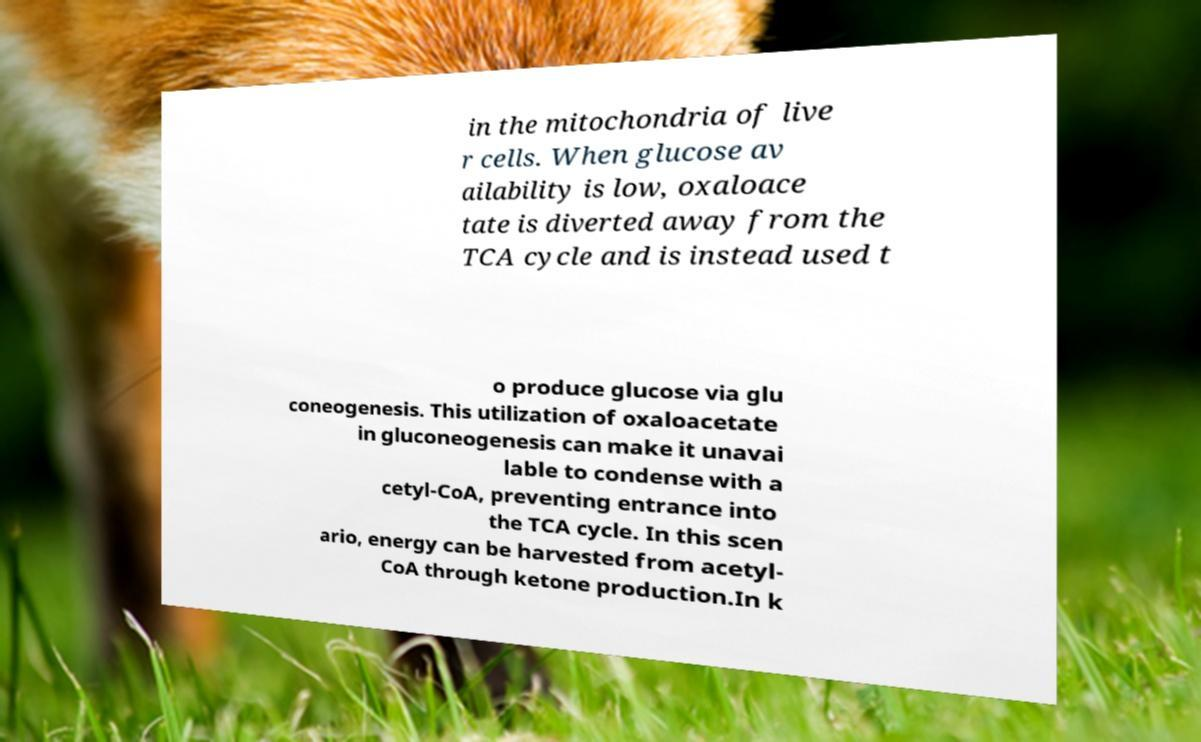Could you assist in decoding the text presented in this image and type it out clearly? in the mitochondria of live r cells. When glucose av ailability is low, oxaloace tate is diverted away from the TCA cycle and is instead used t o produce glucose via glu coneogenesis. This utilization of oxaloacetate in gluconeogenesis can make it unavai lable to condense with a cetyl-CoA, preventing entrance into the TCA cycle. In this scen ario, energy can be harvested from acetyl- CoA through ketone production.In k 